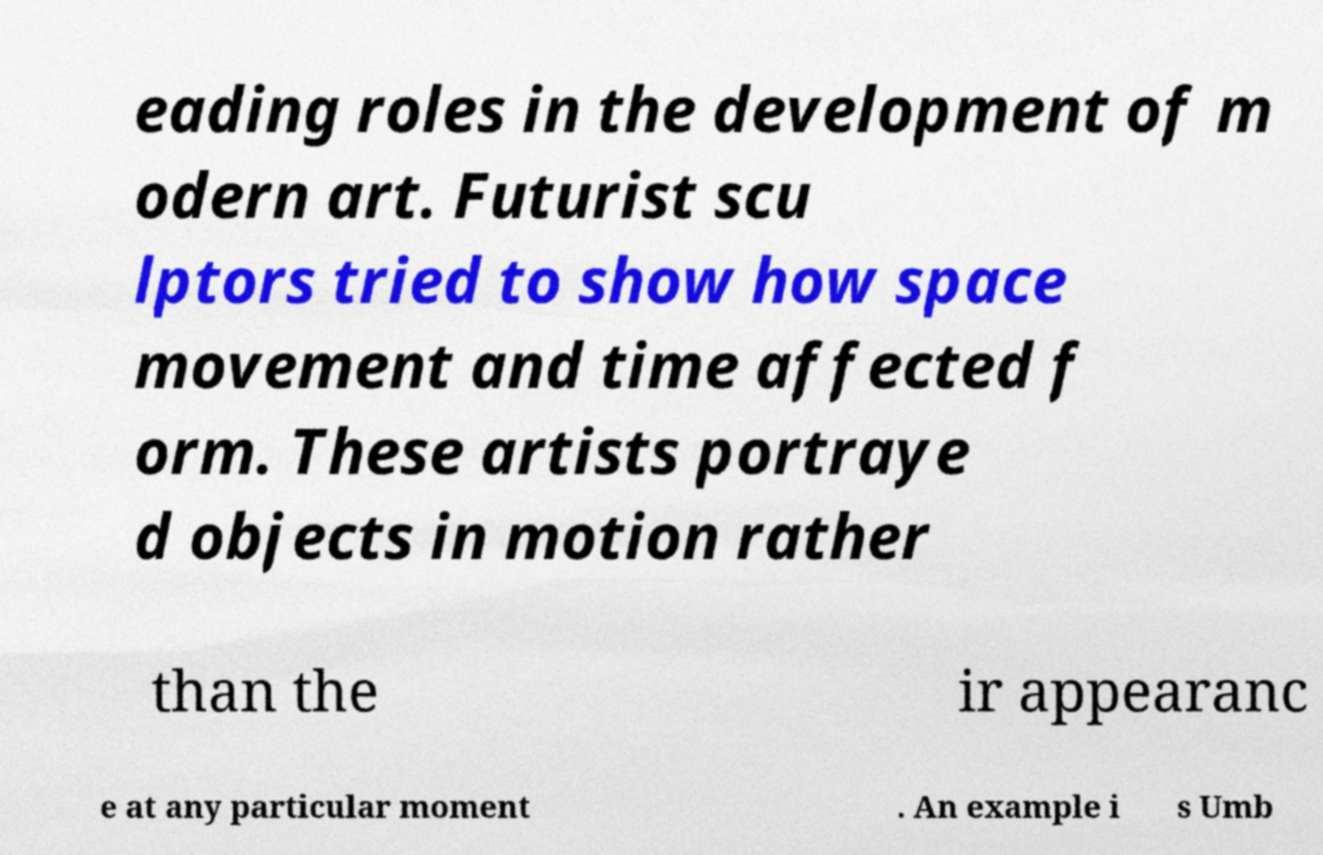Please identify and transcribe the text found in this image. eading roles in the development of m odern art. Futurist scu lptors tried to show how space movement and time affected f orm. These artists portraye d objects in motion rather than the ir appearanc e at any particular moment . An example i s Umb 